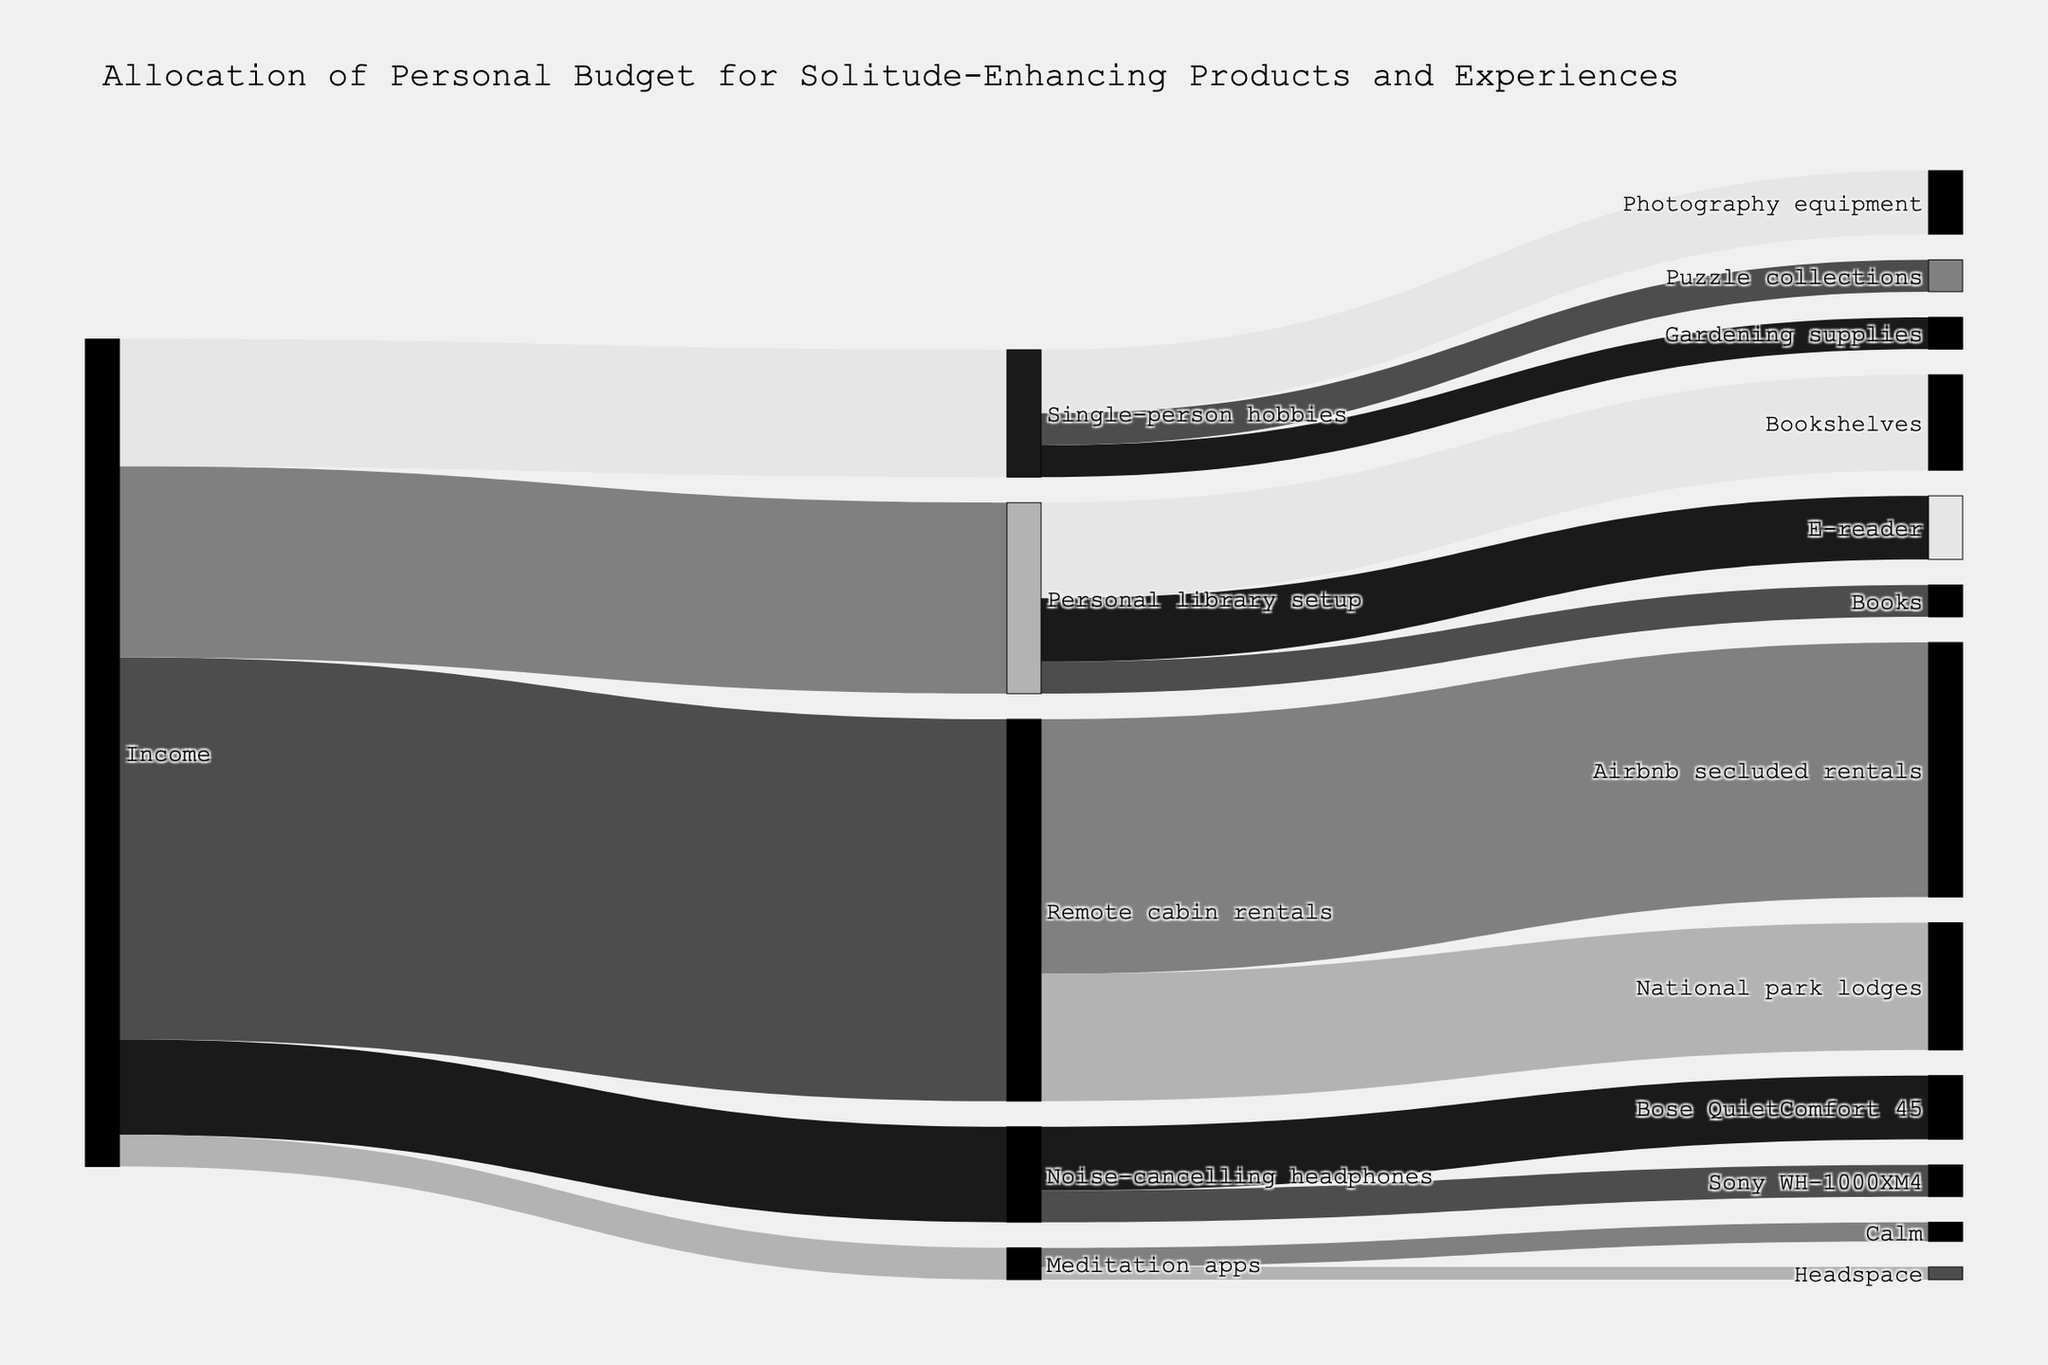What is the title of the figure? The title is displayed at the top of the figure, clearly indicating the main subject of the visualization.
Answer: Allocation of Personal Budget for Solitude-Enhancing Products and Experiences Which product category consumes the highest budget from Income? The figure shows five categories flowing from Income, with varying widths of connection. The widest connection indicates the highest budget allocation.
Answer: Remote cabin rentals How much of the budget is spent on Books under Personal library setup? Locate the "Personal library setup" node, follow its connections to "Books," and observe the value associated with that connection.
Answer: 50 Is the budget allocated to Sony WH-1000XM4 greater than or less than the budget allocated to Bose QuietComfort 45? Compare the width of the connections from "Noise-cancelling headphones" to both "Sony WH-1000XM4" and "Bose QuietComfort 45". The width represents the budget allocation.
Answer: Less than What is the total budget allocated to Single-person hobbies? The figure shows multiple connections flowing from "Single-person hobbies." Sum the values associated with these connections to get the total budget.
Answer: 200 Compare the budget allocations to Airbnb secluded rentals and National park lodges under Remote cabin rentals. Which one is higher and by how much? Check the connections from "Remote cabin rentals" to "Airbnb secluded rentals" and "National park lodges", then compute the difference between these two values.
Answer: Airbnb secluded rentals by 200 What is the combined budget for Meditation apps? Both "Calm" and "Headspace" are under "Meditation apps." Add their values to find the total budget for this category.
Answer: 50 What portion of the budget is spent on Noise-cancelling headphones and its sub-categories combined? Sum the values for all connections flowing from "Noise-cancelling headphones" node to its sub-categories. It includes Bose QuietComfort 45 and Sony WH-1000XM4.
Answer: 150 Which category under Personal library setup has the lowest budget allocation? By identifying the connections under "Personal library setup," observe and compare their widths. The connection with the smallest width represents the lowest budget allocation.
Answer: Books How does the budget allocation to Gardening supplies compare to that of Puzzle collections? Both are subcategories under "Single-person hobbies." Compare the values of the connections flowing from "Single-person hobbies" to "Gardening supplies" and "Puzzle collections."
Answer: Equal 